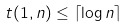Convert formula to latex. <formula><loc_0><loc_0><loc_500><loc_500>t ( 1 , n ) \leq \lceil \log n \rceil</formula> 